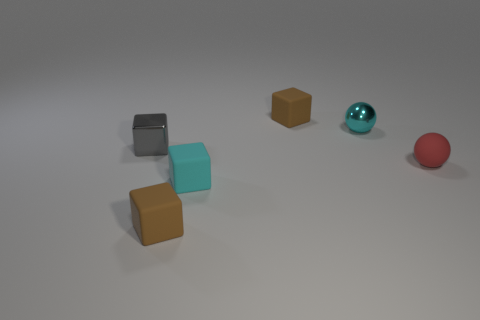There is a matte block that is behind the tiny gray object; what is its color?
Ensure brevity in your answer.  Brown. How many tiny gray objects are in front of the small brown matte thing in front of the tiny object that is behind the small cyan shiny object?
Your response must be concise. 0. There is a small rubber block that is behind the small rubber ball; what number of small cyan things are on the left side of it?
Your response must be concise. 1. There is a shiny cube; what number of tiny metallic things are behind it?
Provide a short and direct response. 1. What number of other things are there of the same size as the cyan shiny thing?
Offer a terse response. 5. What is the size of the cyan rubber thing that is the same shape as the tiny gray shiny object?
Ensure brevity in your answer.  Small. What is the shape of the tiny object that is to the right of the tiny cyan sphere?
Give a very brief answer. Sphere. There is a tiny sphere that is to the left of the thing that is to the right of the metallic sphere; what is its color?
Keep it short and to the point. Cyan. What number of objects are small rubber blocks that are behind the matte sphere or gray things?
Your answer should be compact. 2. How many tiny objects are brown blocks or cyan blocks?
Keep it short and to the point. 3. 